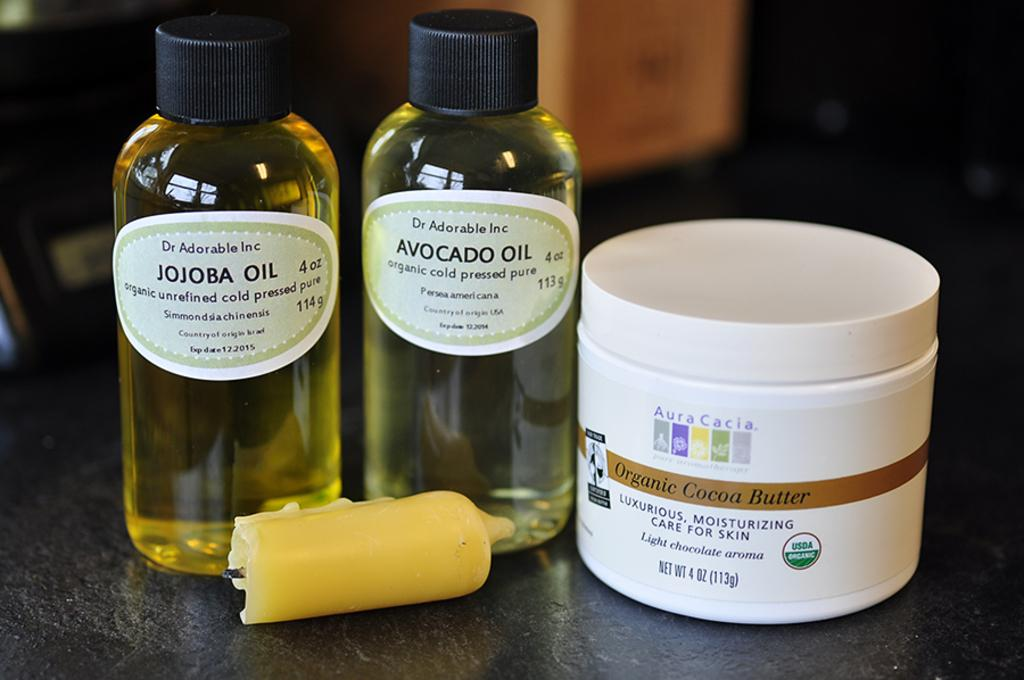Provide a one-sentence caption for the provided image. Bottle of Jojoba Oil next to a bottle of Avocado Oil. 